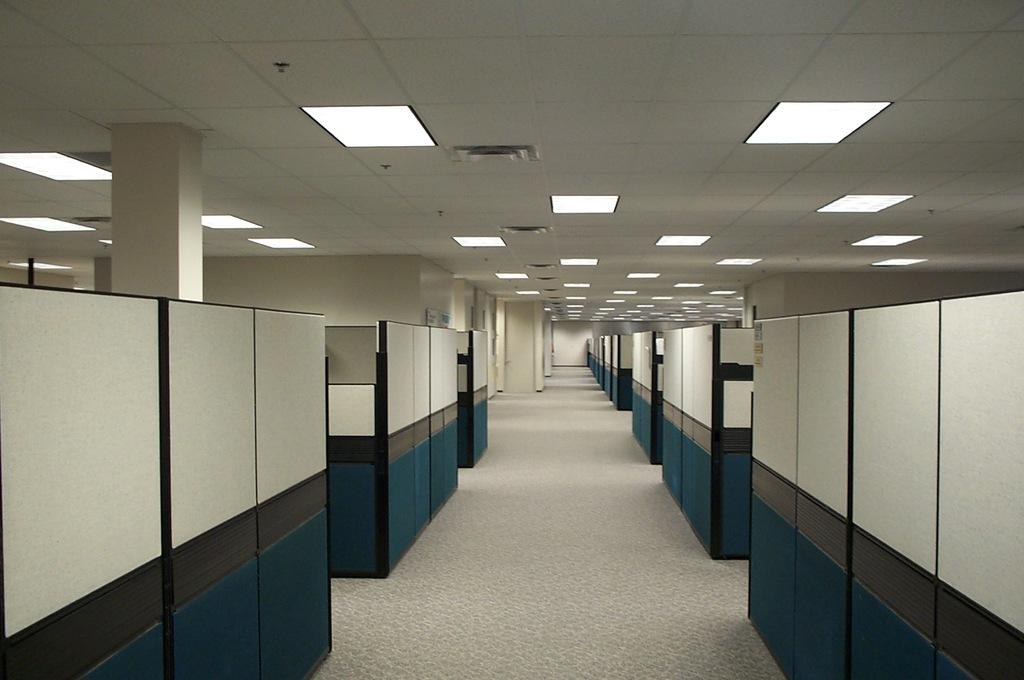What type of location is depicted in the image? The image shows an inner view of a building. What specific features can be seen inside the building? There are cabins visible in the image. What type of lighting is present in the image? There are lights on the ceiling. What might be the purpose of this location based on the visible features? The setting appears to be an office. How does the worm feel about the rule in the image? There is no worm or rule present in the image. 